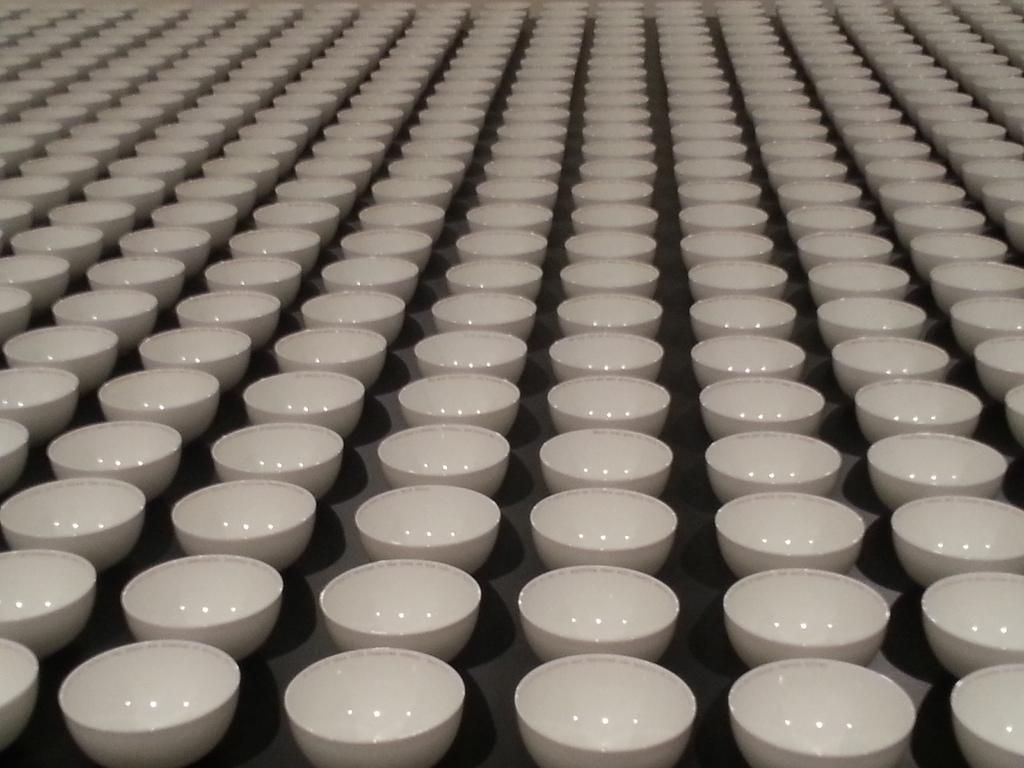What is the color of the surface in the image? The surface in the image is black. How many bowls are visible on the surface? There are multiple bowls onls on the surface. What is the color of the bowls? The bowls are white in color. What type of addition can be heard in the voice of the person in the image? There is no person present in the image, and therefore no voice or addition can be heard. 